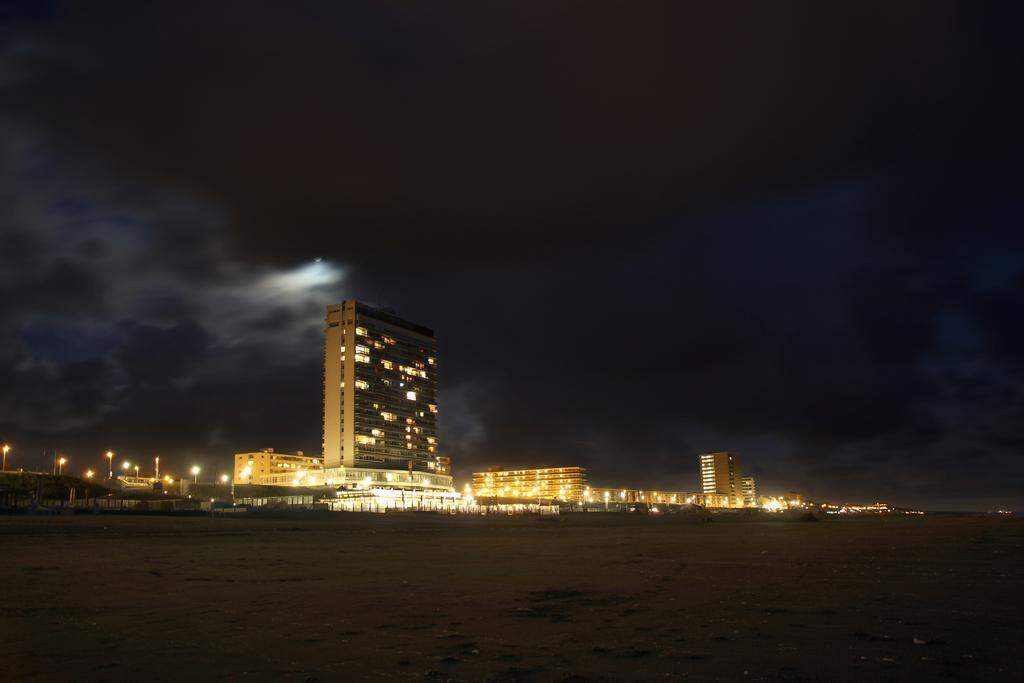How would you summarize this image in a sentence or two? In this image I can see buildings, towers, street lights, vehicles on the road, windows, ground, trees, fence and the sky. This image is taken may be during night. 